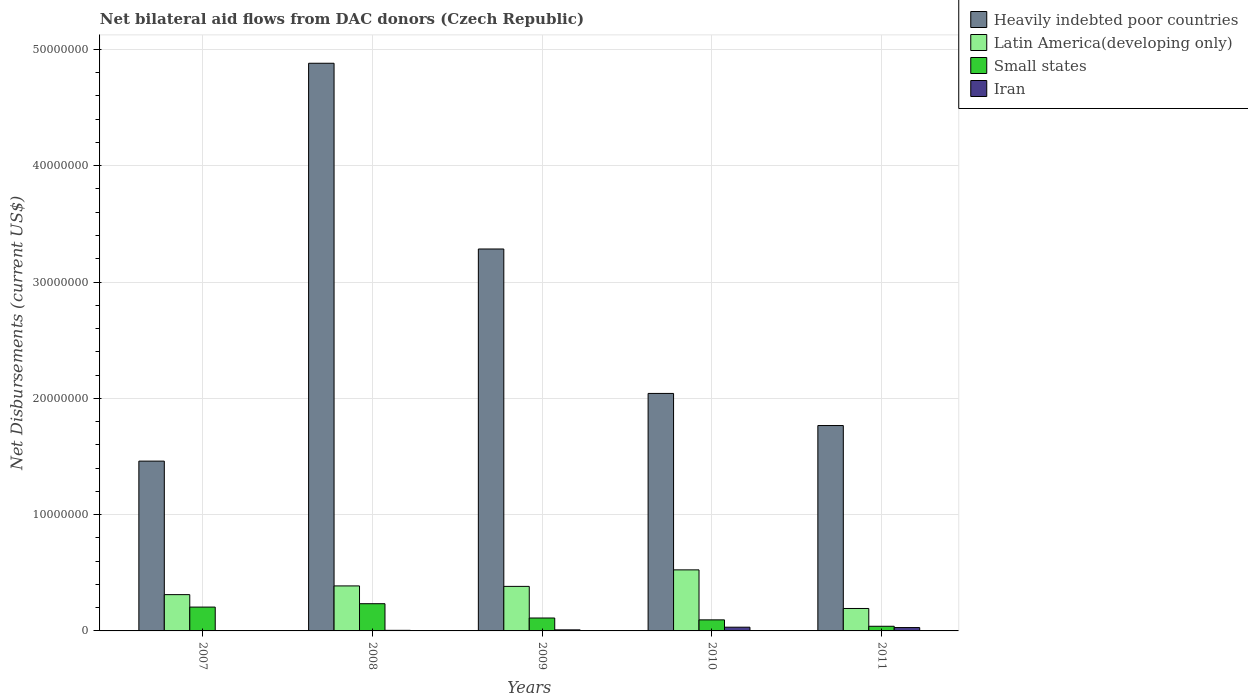How many different coloured bars are there?
Your answer should be compact. 4. How many groups of bars are there?
Make the answer very short. 5. Are the number of bars per tick equal to the number of legend labels?
Provide a succinct answer. Yes. Are the number of bars on each tick of the X-axis equal?
Give a very brief answer. Yes. How many bars are there on the 2nd tick from the left?
Your answer should be very brief. 4. What is the label of the 1st group of bars from the left?
Keep it short and to the point. 2007. In how many cases, is the number of bars for a given year not equal to the number of legend labels?
Offer a terse response. 0. What is the net bilateral aid flows in Iran in 2011?
Keep it short and to the point. 2.90e+05. Across all years, what is the maximum net bilateral aid flows in Heavily indebted poor countries?
Your answer should be compact. 4.88e+07. Across all years, what is the minimum net bilateral aid flows in Latin America(developing only)?
Offer a very short reply. 1.93e+06. In which year was the net bilateral aid flows in Iran minimum?
Provide a succinct answer. 2007. What is the total net bilateral aid flows in Small states in the graph?
Your answer should be very brief. 6.85e+06. What is the difference between the net bilateral aid flows in Heavily indebted poor countries in 2008 and that in 2009?
Your answer should be very brief. 1.60e+07. What is the difference between the net bilateral aid flows in Heavily indebted poor countries in 2007 and the net bilateral aid flows in Small states in 2011?
Your answer should be very brief. 1.42e+07. What is the average net bilateral aid flows in Iran per year?
Your answer should be compact. 1.54e+05. In the year 2008, what is the difference between the net bilateral aid flows in Latin America(developing only) and net bilateral aid flows in Heavily indebted poor countries?
Offer a terse response. -4.49e+07. What is the ratio of the net bilateral aid flows in Iran in 2008 to that in 2010?
Your answer should be very brief. 0.16. What is the difference between the highest and the lowest net bilateral aid flows in Small states?
Ensure brevity in your answer.  1.94e+06. In how many years, is the net bilateral aid flows in Small states greater than the average net bilateral aid flows in Small states taken over all years?
Provide a succinct answer. 2. Is the sum of the net bilateral aid flows in Latin America(developing only) in 2009 and 2010 greater than the maximum net bilateral aid flows in Small states across all years?
Ensure brevity in your answer.  Yes. What does the 4th bar from the left in 2011 represents?
Your response must be concise. Iran. What does the 4th bar from the right in 2007 represents?
Your answer should be very brief. Heavily indebted poor countries. How many bars are there?
Your response must be concise. 20. How many years are there in the graph?
Give a very brief answer. 5. Are the values on the major ticks of Y-axis written in scientific E-notation?
Make the answer very short. No. How are the legend labels stacked?
Your answer should be compact. Vertical. What is the title of the graph?
Your response must be concise. Net bilateral aid flows from DAC donors (Czech Republic). Does "Brazil" appear as one of the legend labels in the graph?
Provide a short and direct response. No. What is the label or title of the X-axis?
Offer a very short reply. Years. What is the label or title of the Y-axis?
Offer a very short reply. Net Disbursements (current US$). What is the Net Disbursements (current US$) of Heavily indebted poor countries in 2007?
Your answer should be very brief. 1.46e+07. What is the Net Disbursements (current US$) in Latin America(developing only) in 2007?
Provide a short and direct response. 3.12e+06. What is the Net Disbursements (current US$) of Small states in 2007?
Your response must be concise. 2.05e+06. What is the Net Disbursements (current US$) in Heavily indebted poor countries in 2008?
Provide a short and direct response. 4.88e+07. What is the Net Disbursements (current US$) of Latin America(developing only) in 2008?
Give a very brief answer. 3.87e+06. What is the Net Disbursements (current US$) in Small states in 2008?
Provide a succinct answer. 2.34e+06. What is the Net Disbursements (current US$) of Heavily indebted poor countries in 2009?
Your response must be concise. 3.28e+07. What is the Net Disbursements (current US$) of Latin America(developing only) in 2009?
Your answer should be compact. 3.83e+06. What is the Net Disbursements (current US$) in Small states in 2009?
Provide a short and direct response. 1.11e+06. What is the Net Disbursements (current US$) in Iran in 2009?
Provide a succinct answer. 9.00e+04. What is the Net Disbursements (current US$) in Heavily indebted poor countries in 2010?
Provide a succinct answer. 2.04e+07. What is the Net Disbursements (current US$) in Latin America(developing only) in 2010?
Your answer should be very brief. 5.25e+06. What is the Net Disbursements (current US$) in Small states in 2010?
Offer a terse response. 9.50e+05. What is the Net Disbursements (current US$) in Heavily indebted poor countries in 2011?
Make the answer very short. 1.77e+07. What is the Net Disbursements (current US$) in Latin America(developing only) in 2011?
Your answer should be very brief. 1.93e+06. What is the Net Disbursements (current US$) in Small states in 2011?
Your response must be concise. 4.00e+05. Across all years, what is the maximum Net Disbursements (current US$) of Heavily indebted poor countries?
Your response must be concise. 4.88e+07. Across all years, what is the maximum Net Disbursements (current US$) of Latin America(developing only)?
Provide a short and direct response. 5.25e+06. Across all years, what is the maximum Net Disbursements (current US$) of Small states?
Provide a succinct answer. 2.34e+06. Across all years, what is the minimum Net Disbursements (current US$) in Heavily indebted poor countries?
Offer a terse response. 1.46e+07. Across all years, what is the minimum Net Disbursements (current US$) of Latin America(developing only)?
Make the answer very short. 1.93e+06. Across all years, what is the minimum Net Disbursements (current US$) of Small states?
Offer a terse response. 4.00e+05. Across all years, what is the minimum Net Disbursements (current US$) of Iran?
Offer a very short reply. 2.00e+04. What is the total Net Disbursements (current US$) of Heavily indebted poor countries in the graph?
Keep it short and to the point. 1.34e+08. What is the total Net Disbursements (current US$) in Latin America(developing only) in the graph?
Your answer should be compact. 1.80e+07. What is the total Net Disbursements (current US$) in Small states in the graph?
Your response must be concise. 6.85e+06. What is the total Net Disbursements (current US$) in Iran in the graph?
Your response must be concise. 7.70e+05. What is the difference between the Net Disbursements (current US$) of Heavily indebted poor countries in 2007 and that in 2008?
Offer a very short reply. -3.42e+07. What is the difference between the Net Disbursements (current US$) of Latin America(developing only) in 2007 and that in 2008?
Keep it short and to the point. -7.50e+05. What is the difference between the Net Disbursements (current US$) of Small states in 2007 and that in 2008?
Offer a terse response. -2.90e+05. What is the difference between the Net Disbursements (current US$) of Iran in 2007 and that in 2008?
Your response must be concise. -3.00e+04. What is the difference between the Net Disbursements (current US$) of Heavily indebted poor countries in 2007 and that in 2009?
Give a very brief answer. -1.82e+07. What is the difference between the Net Disbursements (current US$) of Latin America(developing only) in 2007 and that in 2009?
Your answer should be compact. -7.10e+05. What is the difference between the Net Disbursements (current US$) of Small states in 2007 and that in 2009?
Your answer should be compact. 9.40e+05. What is the difference between the Net Disbursements (current US$) in Heavily indebted poor countries in 2007 and that in 2010?
Ensure brevity in your answer.  -5.82e+06. What is the difference between the Net Disbursements (current US$) in Latin America(developing only) in 2007 and that in 2010?
Provide a short and direct response. -2.13e+06. What is the difference between the Net Disbursements (current US$) in Small states in 2007 and that in 2010?
Make the answer very short. 1.10e+06. What is the difference between the Net Disbursements (current US$) in Heavily indebted poor countries in 2007 and that in 2011?
Provide a succinct answer. -3.06e+06. What is the difference between the Net Disbursements (current US$) of Latin America(developing only) in 2007 and that in 2011?
Offer a very short reply. 1.19e+06. What is the difference between the Net Disbursements (current US$) in Small states in 2007 and that in 2011?
Ensure brevity in your answer.  1.65e+06. What is the difference between the Net Disbursements (current US$) of Heavily indebted poor countries in 2008 and that in 2009?
Offer a very short reply. 1.60e+07. What is the difference between the Net Disbursements (current US$) in Small states in 2008 and that in 2009?
Offer a very short reply. 1.23e+06. What is the difference between the Net Disbursements (current US$) of Heavily indebted poor countries in 2008 and that in 2010?
Offer a terse response. 2.84e+07. What is the difference between the Net Disbursements (current US$) of Latin America(developing only) in 2008 and that in 2010?
Your answer should be very brief. -1.38e+06. What is the difference between the Net Disbursements (current US$) of Small states in 2008 and that in 2010?
Offer a very short reply. 1.39e+06. What is the difference between the Net Disbursements (current US$) of Iran in 2008 and that in 2010?
Your answer should be compact. -2.70e+05. What is the difference between the Net Disbursements (current US$) in Heavily indebted poor countries in 2008 and that in 2011?
Provide a succinct answer. 3.12e+07. What is the difference between the Net Disbursements (current US$) in Latin America(developing only) in 2008 and that in 2011?
Your answer should be compact. 1.94e+06. What is the difference between the Net Disbursements (current US$) in Small states in 2008 and that in 2011?
Offer a terse response. 1.94e+06. What is the difference between the Net Disbursements (current US$) in Iran in 2008 and that in 2011?
Offer a very short reply. -2.40e+05. What is the difference between the Net Disbursements (current US$) of Heavily indebted poor countries in 2009 and that in 2010?
Provide a short and direct response. 1.24e+07. What is the difference between the Net Disbursements (current US$) of Latin America(developing only) in 2009 and that in 2010?
Give a very brief answer. -1.42e+06. What is the difference between the Net Disbursements (current US$) of Small states in 2009 and that in 2010?
Your answer should be very brief. 1.60e+05. What is the difference between the Net Disbursements (current US$) in Heavily indebted poor countries in 2009 and that in 2011?
Provide a short and direct response. 1.52e+07. What is the difference between the Net Disbursements (current US$) of Latin America(developing only) in 2009 and that in 2011?
Your answer should be compact. 1.90e+06. What is the difference between the Net Disbursements (current US$) of Small states in 2009 and that in 2011?
Provide a succinct answer. 7.10e+05. What is the difference between the Net Disbursements (current US$) of Iran in 2009 and that in 2011?
Give a very brief answer. -2.00e+05. What is the difference between the Net Disbursements (current US$) in Heavily indebted poor countries in 2010 and that in 2011?
Make the answer very short. 2.76e+06. What is the difference between the Net Disbursements (current US$) in Latin America(developing only) in 2010 and that in 2011?
Provide a succinct answer. 3.32e+06. What is the difference between the Net Disbursements (current US$) of Iran in 2010 and that in 2011?
Provide a succinct answer. 3.00e+04. What is the difference between the Net Disbursements (current US$) in Heavily indebted poor countries in 2007 and the Net Disbursements (current US$) in Latin America(developing only) in 2008?
Your response must be concise. 1.07e+07. What is the difference between the Net Disbursements (current US$) in Heavily indebted poor countries in 2007 and the Net Disbursements (current US$) in Small states in 2008?
Your answer should be very brief. 1.23e+07. What is the difference between the Net Disbursements (current US$) of Heavily indebted poor countries in 2007 and the Net Disbursements (current US$) of Iran in 2008?
Your response must be concise. 1.46e+07. What is the difference between the Net Disbursements (current US$) of Latin America(developing only) in 2007 and the Net Disbursements (current US$) of Small states in 2008?
Provide a short and direct response. 7.80e+05. What is the difference between the Net Disbursements (current US$) of Latin America(developing only) in 2007 and the Net Disbursements (current US$) of Iran in 2008?
Offer a terse response. 3.07e+06. What is the difference between the Net Disbursements (current US$) in Heavily indebted poor countries in 2007 and the Net Disbursements (current US$) in Latin America(developing only) in 2009?
Make the answer very short. 1.08e+07. What is the difference between the Net Disbursements (current US$) in Heavily indebted poor countries in 2007 and the Net Disbursements (current US$) in Small states in 2009?
Provide a succinct answer. 1.35e+07. What is the difference between the Net Disbursements (current US$) in Heavily indebted poor countries in 2007 and the Net Disbursements (current US$) in Iran in 2009?
Make the answer very short. 1.45e+07. What is the difference between the Net Disbursements (current US$) in Latin America(developing only) in 2007 and the Net Disbursements (current US$) in Small states in 2009?
Provide a succinct answer. 2.01e+06. What is the difference between the Net Disbursements (current US$) of Latin America(developing only) in 2007 and the Net Disbursements (current US$) of Iran in 2009?
Provide a succinct answer. 3.03e+06. What is the difference between the Net Disbursements (current US$) in Small states in 2007 and the Net Disbursements (current US$) in Iran in 2009?
Ensure brevity in your answer.  1.96e+06. What is the difference between the Net Disbursements (current US$) in Heavily indebted poor countries in 2007 and the Net Disbursements (current US$) in Latin America(developing only) in 2010?
Provide a succinct answer. 9.35e+06. What is the difference between the Net Disbursements (current US$) in Heavily indebted poor countries in 2007 and the Net Disbursements (current US$) in Small states in 2010?
Offer a very short reply. 1.36e+07. What is the difference between the Net Disbursements (current US$) in Heavily indebted poor countries in 2007 and the Net Disbursements (current US$) in Iran in 2010?
Make the answer very short. 1.43e+07. What is the difference between the Net Disbursements (current US$) of Latin America(developing only) in 2007 and the Net Disbursements (current US$) of Small states in 2010?
Ensure brevity in your answer.  2.17e+06. What is the difference between the Net Disbursements (current US$) in Latin America(developing only) in 2007 and the Net Disbursements (current US$) in Iran in 2010?
Provide a short and direct response. 2.80e+06. What is the difference between the Net Disbursements (current US$) of Small states in 2007 and the Net Disbursements (current US$) of Iran in 2010?
Your response must be concise. 1.73e+06. What is the difference between the Net Disbursements (current US$) of Heavily indebted poor countries in 2007 and the Net Disbursements (current US$) of Latin America(developing only) in 2011?
Make the answer very short. 1.27e+07. What is the difference between the Net Disbursements (current US$) in Heavily indebted poor countries in 2007 and the Net Disbursements (current US$) in Small states in 2011?
Your answer should be compact. 1.42e+07. What is the difference between the Net Disbursements (current US$) in Heavily indebted poor countries in 2007 and the Net Disbursements (current US$) in Iran in 2011?
Your answer should be compact. 1.43e+07. What is the difference between the Net Disbursements (current US$) of Latin America(developing only) in 2007 and the Net Disbursements (current US$) of Small states in 2011?
Provide a short and direct response. 2.72e+06. What is the difference between the Net Disbursements (current US$) of Latin America(developing only) in 2007 and the Net Disbursements (current US$) of Iran in 2011?
Your answer should be compact. 2.83e+06. What is the difference between the Net Disbursements (current US$) in Small states in 2007 and the Net Disbursements (current US$) in Iran in 2011?
Your answer should be very brief. 1.76e+06. What is the difference between the Net Disbursements (current US$) in Heavily indebted poor countries in 2008 and the Net Disbursements (current US$) in Latin America(developing only) in 2009?
Offer a terse response. 4.50e+07. What is the difference between the Net Disbursements (current US$) of Heavily indebted poor countries in 2008 and the Net Disbursements (current US$) of Small states in 2009?
Keep it short and to the point. 4.77e+07. What is the difference between the Net Disbursements (current US$) in Heavily indebted poor countries in 2008 and the Net Disbursements (current US$) in Iran in 2009?
Your answer should be compact. 4.87e+07. What is the difference between the Net Disbursements (current US$) of Latin America(developing only) in 2008 and the Net Disbursements (current US$) of Small states in 2009?
Offer a terse response. 2.76e+06. What is the difference between the Net Disbursements (current US$) of Latin America(developing only) in 2008 and the Net Disbursements (current US$) of Iran in 2009?
Keep it short and to the point. 3.78e+06. What is the difference between the Net Disbursements (current US$) of Small states in 2008 and the Net Disbursements (current US$) of Iran in 2009?
Offer a very short reply. 2.25e+06. What is the difference between the Net Disbursements (current US$) of Heavily indebted poor countries in 2008 and the Net Disbursements (current US$) of Latin America(developing only) in 2010?
Provide a succinct answer. 4.36e+07. What is the difference between the Net Disbursements (current US$) of Heavily indebted poor countries in 2008 and the Net Disbursements (current US$) of Small states in 2010?
Your answer should be very brief. 4.79e+07. What is the difference between the Net Disbursements (current US$) of Heavily indebted poor countries in 2008 and the Net Disbursements (current US$) of Iran in 2010?
Make the answer very short. 4.85e+07. What is the difference between the Net Disbursements (current US$) of Latin America(developing only) in 2008 and the Net Disbursements (current US$) of Small states in 2010?
Make the answer very short. 2.92e+06. What is the difference between the Net Disbursements (current US$) of Latin America(developing only) in 2008 and the Net Disbursements (current US$) of Iran in 2010?
Keep it short and to the point. 3.55e+06. What is the difference between the Net Disbursements (current US$) in Small states in 2008 and the Net Disbursements (current US$) in Iran in 2010?
Give a very brief answer. 2.02e+06. What is the difference between the Net Disbursements (current US$) in Heavily indebted poor countries in 2008 and the Net Disbursements (current US$) in Latin America(developing only) in 2011?
Offer a very short reply. 4.69e+07. What is the difference between the Net Disbursements (current US$) in Heavily indebted poor countries in 2008 and the Net Disbursements (current US$) in Small states in 2011?
Your response must be concise. 4.84e+07. What is the difference between the Net Disbursements (current US$) of Heavily indebted poor countries in 2008 and the Net Disbursements (current US$) of Iran in 2011?
Your response must be concise. 4.85e+07. What is the difference between the Net Disbursements (current US$) of Latin America(developing only) in 2008 and the Net Disbursements (current US$) of Small states in 2011?
Make the answer very short. 3.47e+06. What is the difference between the Net Disbursements (current US$) in Latin America(developing only) in 2008 and the Net Disbursements (current US$) in Iran in 2011?
Your answer should be very brief. 3.58e+06. What is the difference between the Net Disbursements (current US$) of Small states in 2008 and the Net Disbursements (current US$) of Iran in 2011?
Give a very brief answer. 2.05e+06. What is the difference between the Net Disbursements (current US$) in Heavily indebted poor countries in 2009 and the Net Disbursements (current US$) in Latin America(developing only) in 2010?
Offer a very short reply. 2.76e+07. What is the difference between the Net Disbursements (current US$) in Heavily indebted poor countries in 2009 and the Net Disbursements (current US$) in Small states in 2010?
Your answer should be very brief. 3.19e+07. What is the difference between the Net Disbursements (current US$) of Heavily indebted poor countries in 2009 and the Net Disbursements (current US$) of Iran in 2010?
Your response must be concise. 3.25e+07. What is the difference between the Net Disbursements (current US$) of Latin America(developing only) in 2009 and the Net Disbursements (current US$) of Small states in 2010?
Give a very brief answer. 2.88e+06. What is the difference between the Net Disbursements (current US$) in Latin America(developing only) in 2009 and the Net Disbursements (current US$) in Iran in 2010?
Make the answer very short. 3.51e+06. What is the difference between the Net Disbursements (current US$) in Small states in 2009 and the Net Disbursements (current US$) in Iran in 2010?
Your answer should be compact. 7.90e+05. What is the difference between the Net Disbursements (current US$) of Heavily indebted poor countries in 2009 and the Net Disbursements (current US$) of Latin America(developing only) in 2011?
Keep it short and to the point. 3.09e+07. What is the difference between the Net Disbursements (current US$) in Heavily indebted poor countries in 2009 and the Net Disbursements (current US$) in Small states in 2011?
Ensure brevity in your answer.  3.24e+07. What is the difference between the Net Disbursements (current US$) of Heavily indebted poor countries in 2009 and the Net Disbursements (current US$) of Iran in 2011?
Keep it short and to the point. 3.26e+07. What is the difference between the Net Disbursements (current US$) of Latin America(developing only) in 2009 and the Net Disbursements (current US$) of Small states in 2011?
Make the answer very short. 3.43e+06. What is the difference between the Net Disbursements (current US$) of Latin America(developing only) in 2009 and the Net Disbursements (current US$) of Iran in 2011?
Provide a succinct answer. 3.54e+06. What is the difference between the Net Disbursements (current US$) of Small states in 2009 and the Net Disbursements (current US$) of Iran in 2011?
Provide a short and direct response. 8.20e+05. What is the difference between the Net Disbursements (current US$) of Heavily indebted poor countries in 2010 and the Net Disbursements (current US$) of Latin America(developing only) in 2011?
Provide a short and direct response. 1.85e+07. What is the difference between the Net Disbursements (current US$) of Heavily indebted poor countries in 2010 and the Net Disbursements (current US$) of Small states in 2011?
Offer a terse response. 2.00e+07. What is the difference between the Net Disbursements (current US$) in Heavily indebted poor countries in 2010 and the Net Disbursements (current US$) in Iran in 2011?
Offer a terse response. 2.01e+07. What is the difference between the Net Disbursements (current US$) of Latin America(developing only) in 2010 and the Net Disbursements (current US$) of Small states in 2011?
Make the answer very short. 4.85e+06. What is the difference between the Net Disbursements (current US$) in Latin America(developing only) in 2010 and the Net Disbursements (current US$) in Iran in 2011?
Ensure brevity in your answer.  4.96e+06. What is the difference between the Net Disbursements (current US$) in Small states in 2010 and the Net Disbursements (current US$) in Iran in 2011?
Provide a short and direct response. 6.60e+05. What is the average Net Disbursements (current US$) in Heavily indebted poor countries per year?
Your response must be concise. 2.69e+07. What is the average Net Disbursements (current US$) in Latin America(developing only) per year?
Offer a terse response. 3.60e+06. What is the average Net Disbursements (current US$) in Small states per year?
Offer a terse response. 1.37e+06. What is the average Net Disbursements (current US$) in Iran per year?
Give a very brief answer. 1.54e+05. In the year 2007, what is the difference between the Net Disbursements (current US$) in Heavily indebted poor countries and Net Disbursements (current US$) in Latin America(developing only)?
Give a very brief answer. 1.15e+07. In the year 2007, what is the difference between the Net Disbursements (current US$) in Heavily indebted poor countries and Net Disbursements (current US$) in Small states?
Your response must be concise. 1.26e+07. In the year 2007, what is the difference between the Net Disbursements (current US$) in Heavily indebted poor countries and Net Disbursements (current US$) in Iran?
Ensure brevity in your answer.  1.46e+07. In the year 2007, what is the difference between the Net Disbursements (current US$) in Latin America(developing only) and Net Disbursements (current US$) in Small states?
Ensure brevity in your answer.  1.07e+06. In the year 2007, what is the difference between the Net Disbursements (current US$) of Latin America(developing only) and Net Disbursements (current US$) of Iran?
Ensure brevity in your answer.  3.10e+06. In the year 2007, what is the difference between the Net Disbursements (current US$) of Small states and Net Disbursements (current US$) of Iran?
Your answer should be very brief. 2.03e+06. In the year 2008, what is the difference between the Net Disbursements (current US$) of Heavily indebted poor countries and Net Disbursements (current US$) of Latin America(developing only)?
Provide a short and direct response. 4.49e+07. In the year 2008, what is the difference between the Net Disbursements (current US$) of Heavily indebted poor countries and Net Disbursements (current US$) of Small states?
Offer a terse response. 4.65e+07. In the year 2008, what is the difference between the Net Disbursements (current US$) of Heavily indebted poor countries and Net Disbursements (current US$) of Iran?
Your answer should be compact. 4.88e+07. In the year 2008, what is the difference between the Net Disbursements (current US$) of Latin America(developing only) and Net Disbursements (current US$) of Small states?
Your response must be concise. 1.53e+06. In the year 2008, what is the difference between the Net Disbursements (current US$) of Latin America(developing only) and Net Disbursements (current US$) of Iran?
Ensure brevity in your answer.  3.82e+06. In the year 2008, what is the difference between the Net Disbursements (current US$) of Small states and Net Disbursements (current US$) of Iran?
Your answer should be very brief. 2.29e+06. In the year 2009, what is the difference between the Net Disbursements (current US$) in Heavily indebted poor countries and Net Disbursements (current US$) in Latin America(developing only)?
Your response must be concise. 2.90e+07. In the year 2009, what is the difference between the Net Disbursements (current US$) of Heavily indebted poor countries and Net Disbursements (current US$) of Small states?
Your answer should be compact. 3.17e+07. In the year 2009, what is the difference between the Net Disbursements (current US$) in Heavily indebted poor countries and Net Disbursements (current US$) in Iran?
Offer a very short reply. 3.28e+07. In the year 2009, what is the difference between the Net Disbursements (current US$) of Latin America(developing only) and Net Disbursements (current US$) of Small states?
Ensure brevity in your answer.  2.72e+06. In the year 2009, what is the difference between the Net Disbursements (current US$) of Latin America(developing only) and Net Disbursements (current US$) of Iran?
Ensure brevity in your answer.  3.74e+06. In the year 2009, what is the difference between the Net Disbursements (current US$) in Small states and Net Disbursements (current US$) in Iran?
Keep it short and to the point. 1.02e+06. In the year 2010, what is the difference between the Net Disbursements (current US$) in Heavily indebted poor countries and Net Disbursements (current US$) in Latin America(developing only)?
Ensure brevity in your answer.  1.52e+07. In the year 2010, what is the difference between the Net Disbursements (current US$) in Heavily indebted poor countries and Net Disbursements (current US$) in Small states?
Make the answer very short. 1.95e+07. In the year 2010, what is the difference between the Net Disbursements (current US$) in Heavily indebted poor countries and Net Disbursements (current US$) in Iran?
Provide a short and direct response. 2.01e+07. In the year 2010, what is the difference between the Net Disbursements (current US$) in Latin America(developing only) and Net Disbursements (current US$) in Small states?
Make the answer very short. 4.30e+06. In the year 2010, what is the difference between the Net Disbursements (current US$) in Latin America(developing only) and Net Disbursements (current US$) in Iran?
Keep it short and to the point. 4.93e+06. In the year 2010, what is the difference between the Net Disbursements (current US$) in Small states and Net Disbursements (current US$) in Iran?
Make the answer very short. 6.30e+05. In the year 2011, what is the difference between the Net Disbursements (current US$) of Heavily indebted poor countries and Net Disbursements (current US$) of Latin America(developing only)?
Ensure brevity in your answer.  1.57e+07. In the year 2011, what is the difference between the Net Disbursements (current US$) of Heavily indebted poor countries and Net Disbursements (current US$) of Small states?
Give a very brief answer. 1.73e+07. In the year 2011, what is the difference between the Net Disbursements (current US$) in Heavily indebted poor countries and Net Disbursements (current US$) in Iran?
Ensure brevity in your answer.  1.74e+07. In the year 2011, what is the difference between the Net Disbursements (current US$) in Latin America(developing only) and Net Disbursements (current US$) in Small states?
Your answer should be compact. 1.53e+06. In the year 2011, what is the difference between the Net Disbursements (current US$) in Latin America(developing only) and Net Disbursements (current US$) in Iran?
Your answer should be very brief. 1.64e+06. What is the ratio of the Net Disbursements (current US$) of Heavily indebted poor countries in 2007 to that in 2008?
Provide a succinct answer. 0.3. What is the ratio of the Net Disbursements (current US$) of Latin America(developing only) in 2007 to that in 2008?
Your answer should be compact. 0.81. What is the ratio of the Net Disbursements (current US$) in Small states in 2007 to that in 2008?
Ensure brevity in your answer.  0.88. What is the ratio of the Net Disbursements (current US$) of Iran in 2007 to that in 2008?
Give a very brief answer. 0.4. What is the ratio of the Net Disbursements (current US$) of Heavily indebted poor countries in 2007 to that in 2009?
Keep it short and to the point. 0.44. What is the ratio of the Net Disbursements (current US$) in Latin America(developing only) in 2007 to that in 2009?
Provide a short and direct response. 0.81. What is the ratio of the Net Disbursements (current US$) of Small states in 2007 to that in 2009?
Offer a terse response. 1.85. What is the ratio of the Net Disbursements (current US$) in Iran in 2007 to that in 2009?
Your answer should be compact. 0.22. What is the ratio of the Net Disbursements (current US$) in Heavily indebted poor countries in 2007 to that in 2010?
Provide a succinct answer. 0.71. What is the ratio of the Net Disbursements (current US$) in Latin America(developing only) in 2007 to that in 2010?
Provide a short and direct response. 0.59. What is the ratio of the Net Disbursements (current US$) of Small states in 2007 to that in 2010?
Give a very brief answer. 2.16. What is the ratio of the Net Disbursements (current US$) in Iran in 2007 to that in 2010?
Your answer should be very brief. 0.06. What is the ratio of the Net Disbursements (current US$) of Heavily indebted poor countries in 2007 to that in 2011?
Make the answer very short. 0.83. What is the ratio of the Net Disbursements (current US$) in Latin America(developing only) in 2007 to that in 2011?
Keep it short and to the point. 1.62. What is the ratio of the Net Disbursements (current US$) of Small states in 2007 to that in 2011?
Offer a terse response. 5.12. What is the ratio of the Net Disbursements (current US$) of Iran in 2007 to that in 2011?
Give a very brief answer. 0.07. What is the ratio of the Net Disbursements (current US$) of Heavily indebted poor countries in 2008 to that in 2009?
Ensure brevity in your answer.  1.49. What is the ratio of the Net Disbursements (current US$) of Latin America(developing only) in 2008 to that in 2009?
Your response must be concise. 1.01. What is the ratio of the Net Disbursements (current US$) of Small states in 2008 to that in 2009?
Your response must be concise. 2.11. What is the ratio of the Net Disbursements (current US$) in Iran in 2008 to that in 2009?
Give a very brief answer. 0.56. What is the ratio of the Net Disbursements (current US$) in Heavily indebted poor countries in 2008 to that in 2010?
Your answer should be very brief. 2.39. What is the ratio of the Net Disbursements (current US$) of Latin America(developing only) in 2008 to that in 2010?
Offer a very short reply. 0.74. What is the ratio of the Net Disbursements (current US$) in Small states in 2008 to that in 2010?
Your response must be concise. 2.46. What is the ratio of the Net Disbursements (current US$) in Iran in 2008 to that in 2010?
Offer a very short reply. 0.16. What is the ratio of the Net Disbursements (current US$) of Heavily indebted poor countries in 2008 to that in 2011?
Give a very brief answer. 2.76. What is the ratio of the Net Disbursements (current US$) in Latin America(developing only) in 2008 to that in 2011?
Offer a terse response. 2.01. What is the ratio of the Net Disbursements (current US$) in Small states in 2008 to that in 2011?
Your response must be concise. 5.85. What is the ratio of the Net Disbursements (current US$) in Iran in 2008 to that in 2011?
Give a very brief answer. 0.17. What is the ratio of the Net Disbursements (current US$) in Heavily indebted poor countries in 2009 to that in 2010?
Keep it short and to the point. 1.61. What is the ratio of the Net Disbursements (current US$) in Latin America(developing only) in 2009 to that in 2010?
Give a very brief answer. 0.73. What is the ratio of the Net Disbursements (current US$) in Small states in 2009 to that in 2010?
Keep it short and to the point. 1.17. What is the ratio of the Net Disbursements (current US$) of Iran in 2009 to that in 2010?
Offer a terse response. 0.28. What is the ratio of the Net Disbursements (current US$) in Heavily indebted poor countries in 2009 to that in 2011?
Make the answer very short. 1.86. What is the ratio of the Net Disbursements (current US$) in Latin America(developing only) in 2009 to that in 2011?
Give a very brief answer. 1.98. What is the ratio of the Net Disbursements (current US$) in Small states in 2009 to that in 2011?
Offer a very short reply. 2.77. What is the ratio of the Net Disbursements (current US$) of Iran in 2009 to that in 2011?
Provide a succinct answer. 0.31. What is the ratio of the Net Disbursements (current US$) of Heavily indebted poor countries in 2010 to that in 2011?
Your answer should be very brief. 1.16. What is the ratio of the Net Disbursements (current US$) in Latin America(developing only) in 2010 to that in 2011?
Keep it short and to the point. 2.72. What is the ratio of the Net Disbursements (current US$) in Small states in 2010 to that in 2011?
Provide a succinct answer. 2.38. What is the ratio of the Net Disbursements (current US$) in Iran in 2010 to that in 2011?
Make the answer very short. 1.1. What is the difference between the highest and the second highest Net Disbursements (current US$) of Heavily indebted poor countries?
Provide a succinct answer. 1.60e+07. What is the difference between the highest and the second highest Net Disbursements (current US$) of Latin America(developing only)?
Make the answer very short. 1.38e+06. What is the difference between the highest and the lowest Net Disbursements (current US$) in Heavily indebted poor countries?
Keep it short and to the point. 3.42e+07. What is the difference between the highest and the lowest Net Disbursements (current US$) of Latin America(developing only)?
Your answer should be very brief. 3.32e+06. What is the difference between the highest and the lowest Net Disbursements (current US$) of Small states?
Ensure brevity in your answer.  1.94e+06. What is the difference between the highest and the lowest Net Disbursements (current US$) in Iran?
Provide a short and direct response. 3.00e+05. 